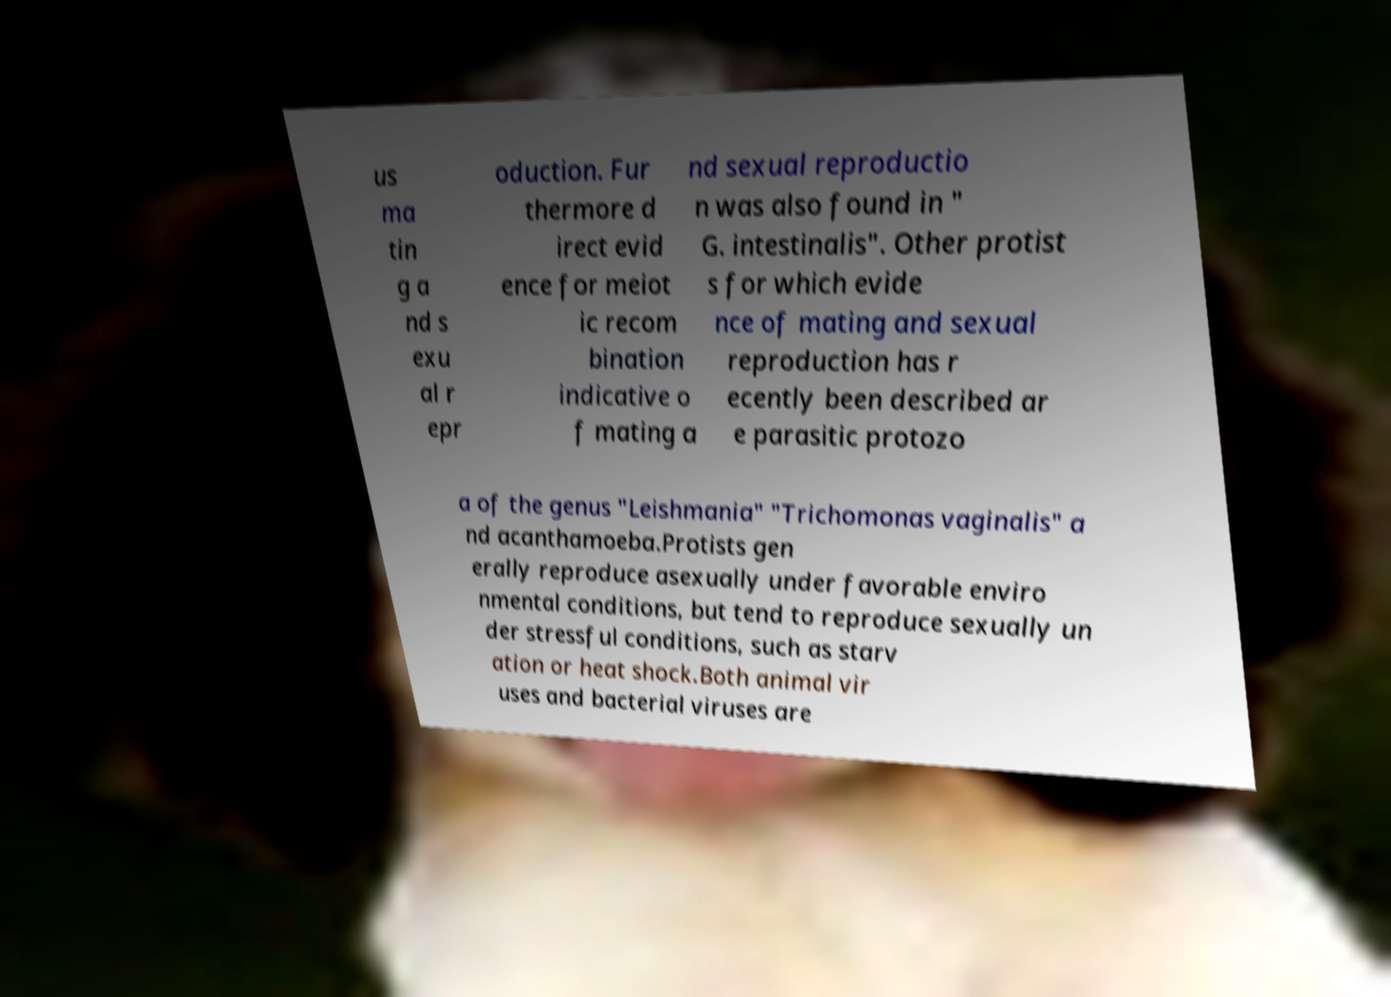Can you read and provide the text displayed in the image?This photo seems to have some interesting text. Can you extract and type it out for me? us ma tin g a nd s exu al r epr oduction. Fur thermore d irect evid ence for meiot ic recom bination indicative o f mating a nd sexual reproductio n was also found in " G. intestinalis". Other protist s for which evide nce of mating and sexual reproduction has r ecently been described ar e parasitic protozo a of the genus "Leishmania" "Trichomonas vaginalis" a nd acanthamoeba.Protists gen erally reproduce asexually under favorable enviro nmental conditions, but tend to reproduce sexually un der stressful conditions, such as starv ation or heat shock.Both animal vir uses and bacterial viruses are 